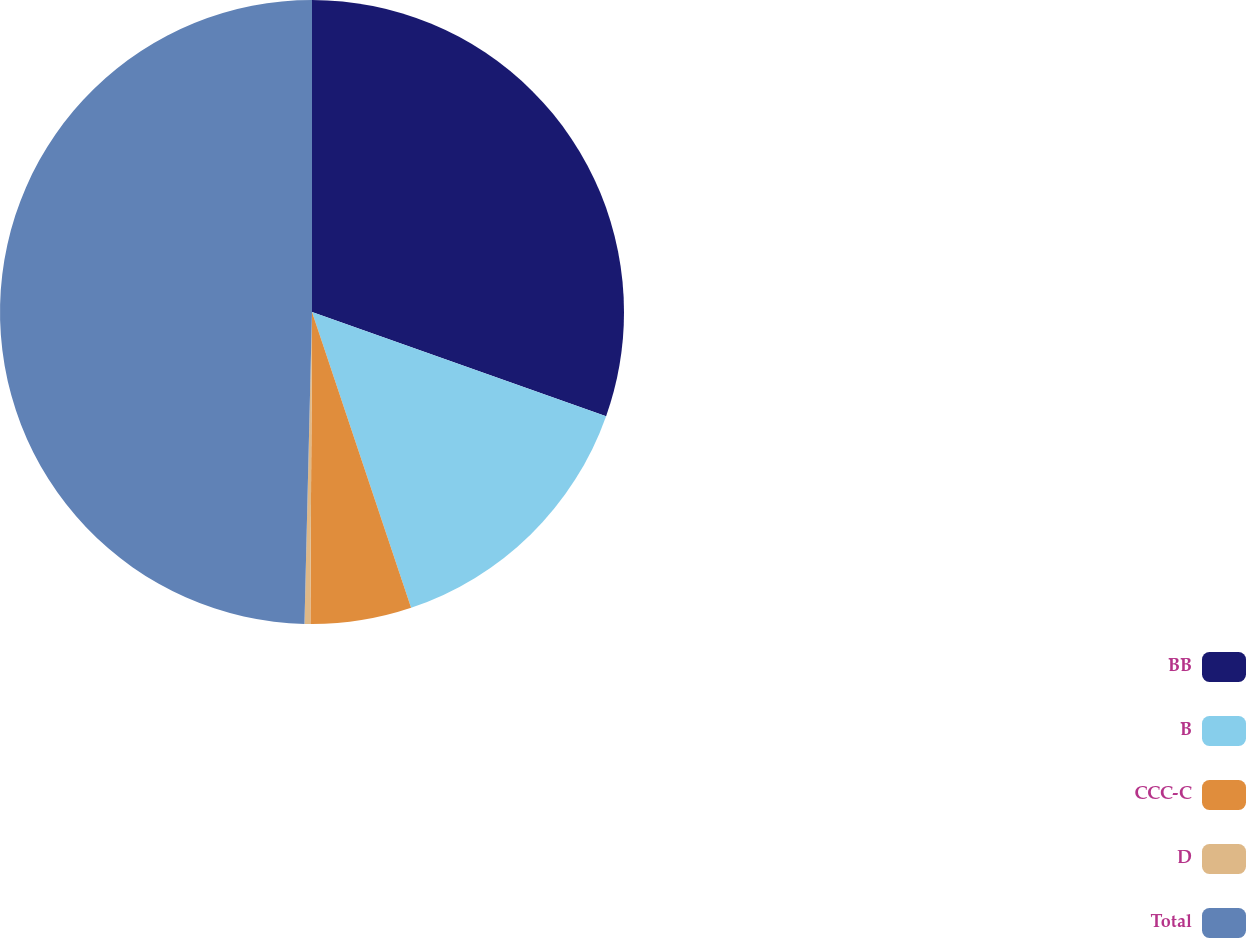<chart> <loc_0><loc_0><loc_500><loc_500><pie_chart><fcel>BB<fcel>B<fcel>CCC-C<fcel>D<fcel>Total<nl><fcel>30.42%<fcel>14.44%<fcel>5.23%<fcel>0.3%<fcel>49.62%<nl></chart> 